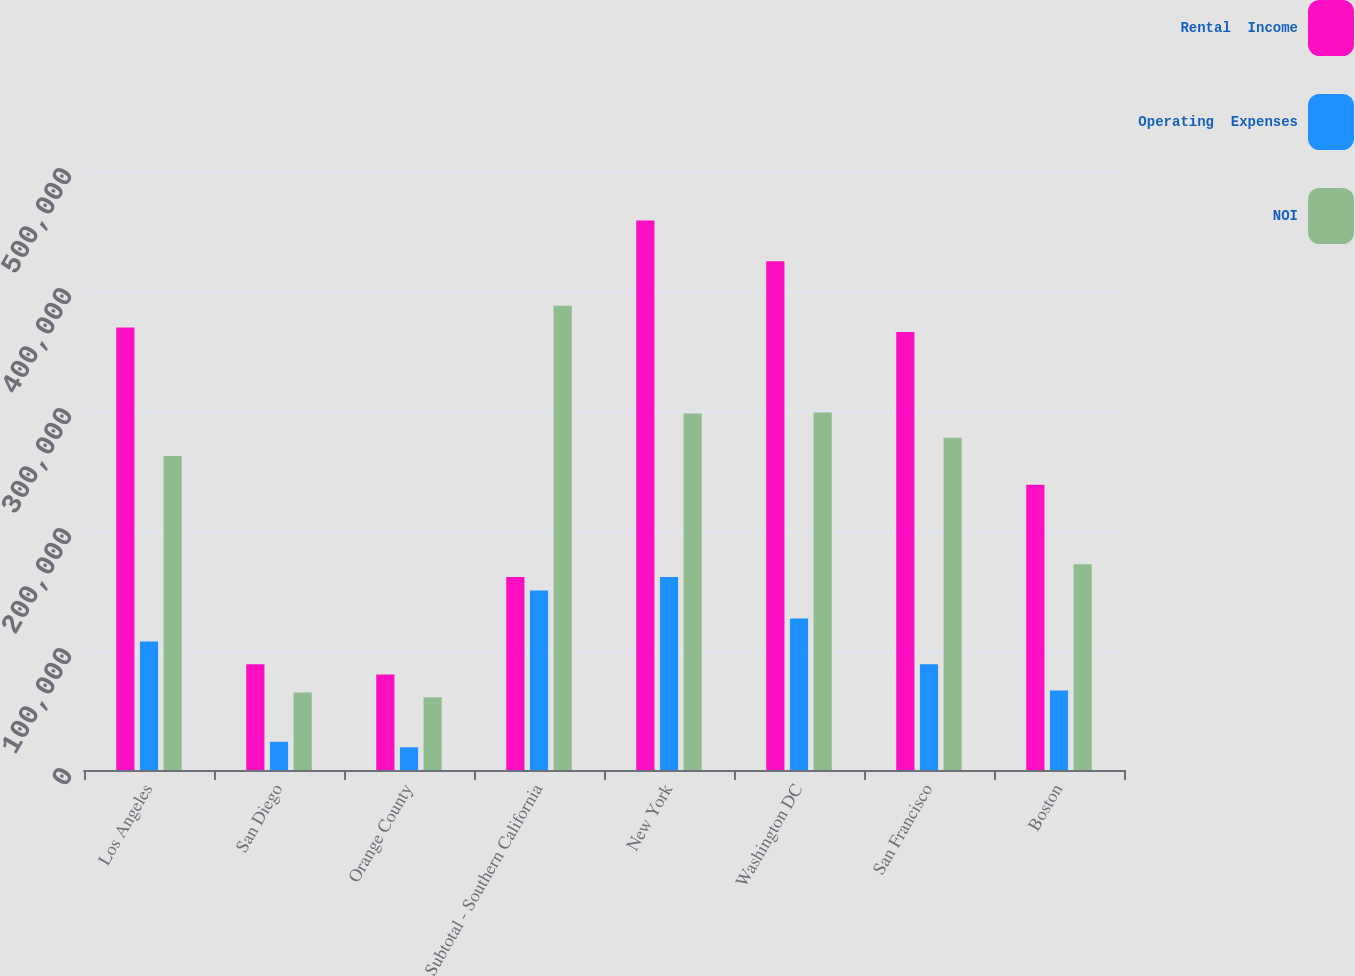Convert chart. <chart><loc_0><loc_0><loc_500><loc_500><stacked_bar_chart><ecel><fcel>Los Angeles<fcel>San Diego<fcel>Orange County<fcel>Subtotal - Southern California<fcel>New York<fcel>Washington DC<fcel>San Francisco<fcel>Boston<nl><fcel>Rental  Income<fcel>368734<fcel>88049<fcel>79602<fcel>160772<fcel>457882<fcel>424055<fcel>365019<fcel>237683<nl><fcel>Operating  Expenses<fcel>107138<fcel>23489<fcel>18931<fcel>149558<fcel>160772<fcel>126154<fcel>88141<fcel>66283<nl><fcel>NOI<fcel>261596<fcel>64560<fcel>60671<fcel>386827<fcel>297110<fcel>297901<fcel>276878<fcel>171400<nl></chart> 